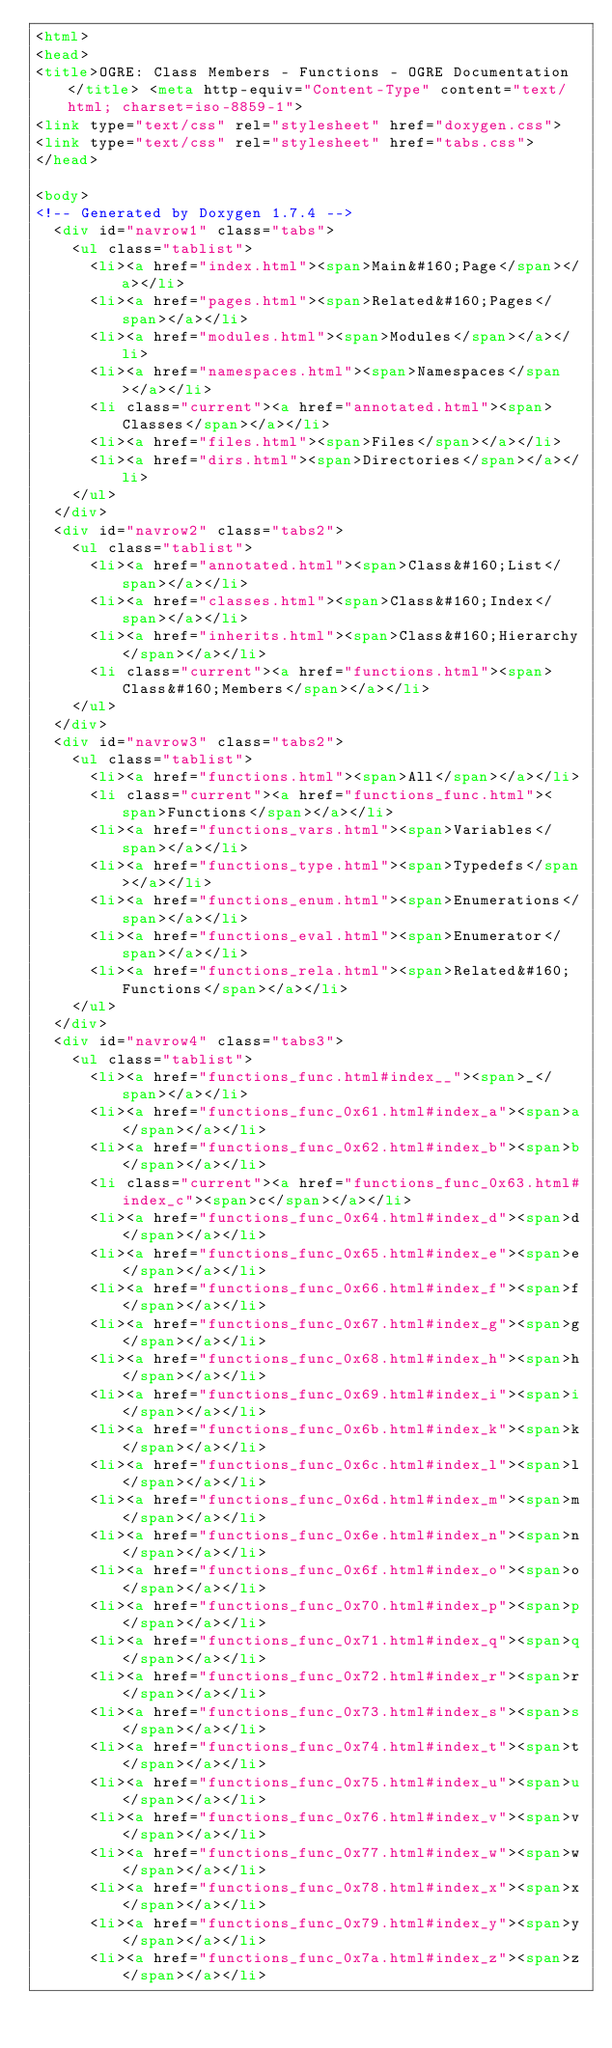Convert code to text. <code><loc_0><loc_0><loc_500><loc_500><_HTML_><html>
<head>
<title>OGRE: Class Members - Functions - OGRE Documentation</title> <meta http-equiv="Content-Type" content="text/html; charset=iso-8859-1"> 
<link type="text/css" rel="stylesheet" href="doxygen.css">
<link type="text/css" rel="stylesheet" href="tabs.css">
</head>

<body>
<!-- Generated by Doxygen 1.7.4 -->
  <div id="navrow1" class="tabs">
    <ul class="tablist">
      <li><a href="index.html"><span>Main&#160;Page</span></a></li>
      <li><a href="pages.html"><span>Related&#160;Pages</span></a></li>
      <li><a href="modules.html"><span>Modules</span></a></li>
      <li><a href="namespaces.html"><span>Namespaces</span></a></li>
      <li class="current"><a href="annotated.html"><span>Classes</span></a></li>
      <li><a href="files.html"><span>Files</span></a></li>
      <li><a href="dirs.html"><span>Directories</span></a></li>
    </ul>
  </div>
  <div id="navrow2" class="tabs2">
    <ul class="tablist">
      <li><a href="annotated.html"><span>Class&#160;List</span></a></li>
      <li><a href="classes.html"><span>Class&#160;Index</span></a></li>
      <li><a href="inherits.html"><span>Class&#160;Hierarchy</span></a></li>
      <li class="current"><a href="functions.html"><span>Class&#160;Members</span></a></li>
    </ul>
  </div>
  <div id="navrow3" class="tabs2">
    <ul class="tablist">
      <li><a href="functions.html"><span>All</span></a></li>
      <li class="current"><a href="functions_func.html"><span>Functions</span></a></li>
      <li><a href="functions_vars.html"><span>Variables</span></a></li>
      <li><a href="functions_type.html"><span>Typedefs</span></a></li>
      <li><a href="functions_enum.html"><span>Enumerations</span></a></li>
      <li><a href="functions_eval.html"><span>Enumerator</span></a></li>
      <li><a href="functions_rela.html"><span>Related&#160;Functions</span></a></li>
    </ul>
  </div>
  <div id="navrow4" class="tabs3">
    <ul class="tablist">
      <li><a href="functions_func.html#index__"><span>_</span></a></li>
      <li><a href="functions_func_0x61.html#index_a"><span>a</span></a></li>
      <li><a href="functions_func_0x62.html#index_b"><span>b</span></a></li>
      <li class="current"><a href="functions_func_0x63.html#index_c"><span>c</span></a></li>
      <li><a href="functions_func_0x64.html#index_d"><span>d</span></a></li>
      <li><a href="functions_func_0x65.html#index_e"><span>e</span></a></li>
      <li><a href="functions_func_0x66.html#index_f"><span>f</span></a></li>
      <li><a href="functions_func_0x67.html#index_g"><span>g</span></a></li>
      <li><a href="functions_func_0x68.html#index_h"><span>h</span></a></li>
      <li><a href="functions_func_0x69.html#index_i"><span>i</span></a></li>
      <li><a href="functions_func_0x6b.html#index_k"><span>k</span></a></li>
      <li><a href="functions_func_0x6c.html#index_l"><span>l</span></a></li>
      <li><a href="functions_func_0x6d.html#index_m"><span>m</span></a></li>
      <li><a href="functions_func_0x6e.html#index_n"><span>n</span></a></li>
      <li><a href="functions_func_0x6f.html#index_o"><span>o</span></a></li>
      <li><a href="functions_func_0x70.html#index_p"><span>p</span></a></li>
      <li><a href="functions_func_0x71.html#index_q"><span>q</span></a></li>
      <li><a href="functions_func_0x72.html#index_r"><span>r</span></a></li>
      <li><a href="functions_func_0x73.html#index_s"><span>s</span></a></li>
      <li><a href="functions_func_0x74.html#index_t"><span>t</span></a></li>
      <li><a href="functions_func_0x75.html#index_u"><span>u</span></a></li>
      <li><a href="functions_func_0x76.html#index_v"><span>v</span></a></li>
      <li><a href="functions_func_0x77.html#index_w"><span>w</span></a></li>
      <li><a href="functions_func_0x78.html#index_x"><span>x</span></a></li>
      <li><a href="functions_func_0x79.html#index_y"><span>y</span></a></li>
      <li><a href="functions_func_0x7a.html#index_z"><span>z</span></a></li></code> 